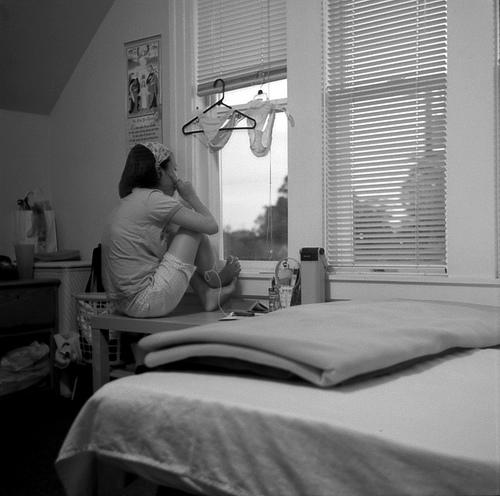Why are the underpants hanging there?

Choices:
A) on display
B) closet full
C) to dry
D) for decoration to dry 